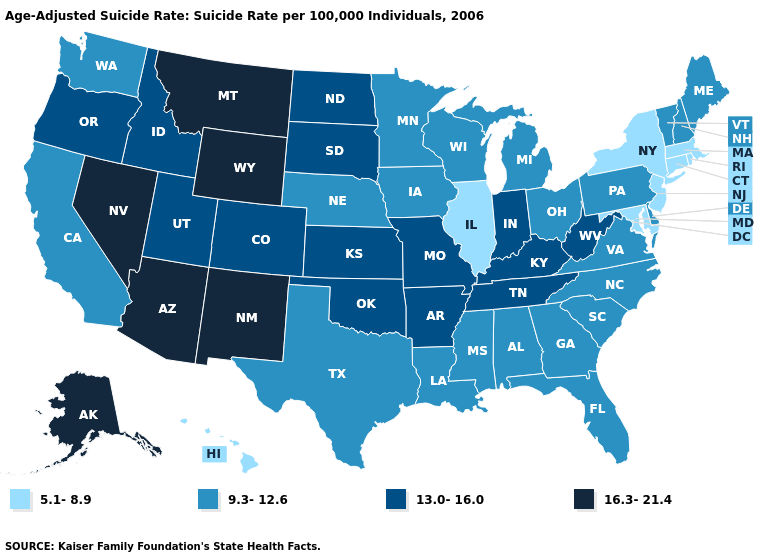Name the states that have a value in the range 9.3-12.6?
Short answer required. Alabama, California, Delaware, Florida, Georgia, Iowa, Louisiana, Maine, Michigan, Minnesota, Mississippi, Nebraska, New Hampshire, North Carolina, Ohio, Pennsylvania, South Carolina, Texas, Vermont, Virginia, Washington, Wisconsin. What is the value of Colorado?
Give a very brief answer. 13.0-16.0. Does the map have missing data?
Give a very brief answer. No. What is the highest value in the USA?
Give a very brief answer. 16.3-21.4. Does California have a lower value than Arizona?
Quick response, please. Yes. Name the states that have a value in the range 13.0-16.0?
Keep it brief. Arkansas, Colorado, Idaho, Indiana, Kansas, Kentucky, Missouri, North Dakota, Oklahoma, Oregon, South Dakota, Tennessee, Utah, West Virginia. What is the value of Michigan?
Quick response, please. 9.3-12.6. How many symbols are there in the legend?
Be succinct. 4. What is the value of Mississippi?
Be succinct. 9.3-12.6. Does Idaho have the same value as Utah?
Give a very brief answer. Yes. Does Iowa have the same value as South Carolina?
Be succinct. Yes. Name the states that have a value in the range 16.3-21.4?
Short answer required. Alaska, Arizona, Montana, Nevada, New Mexico, Wyoming. What is the value of New York?
Quick response, please. 5.1-8.9. Among the states that border Alabama , which have the lowest value?
Answer briefly. Florida, Georgia, Mississippi. What is the value of South Dakota?
Write a very short answer. 13.0-16.0. 